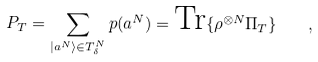<formula> <loc_0><loc_0><loc_500><loc_500>P _ { T } = \sum _ { | a ^ { N } \rangle \in T _ { \delta } ^ { N } } p ( a ^ { N } ) = \text {Tr} \{ \rho ^ { \otimes N } \Pi _ { T } \} \quad ,</formula> 